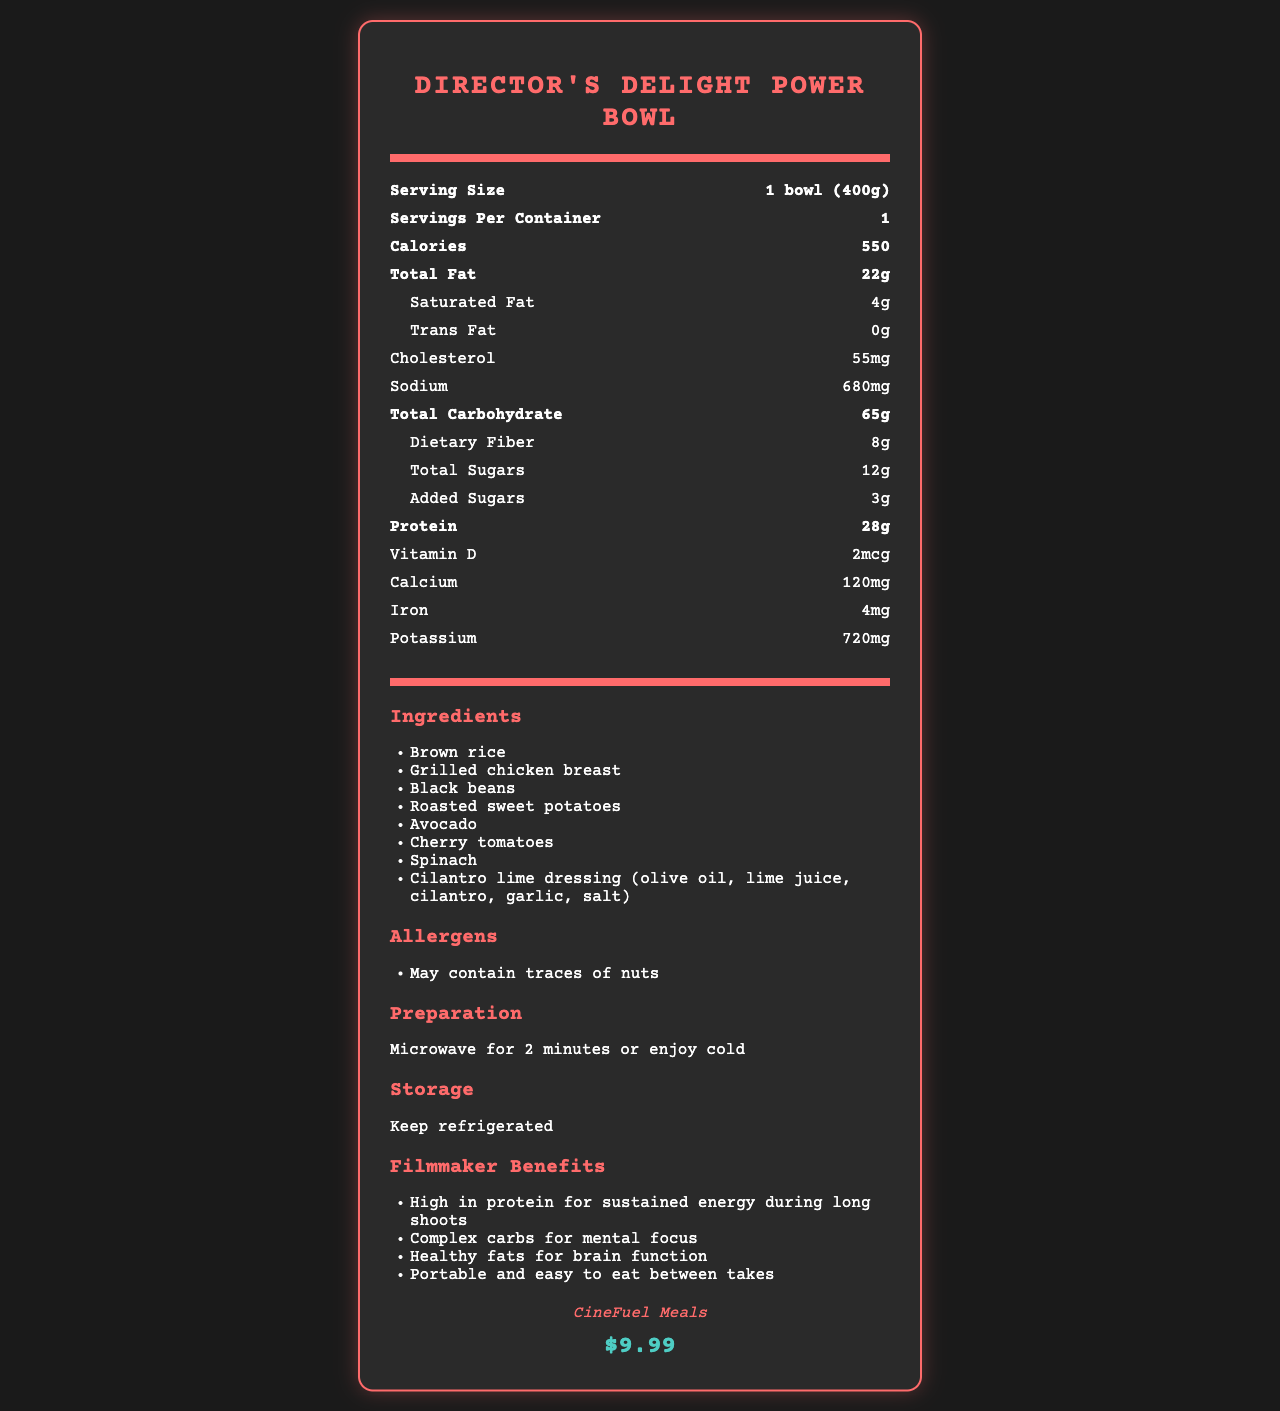what is the serving size of the Director's Delight Power Bowl? The document clearly states that the serving size is "1 bowl (400g)".
Answer: 1 bowl (400g) how many servings are there per container? The document mentions that there is 1 serving per container.
Answer: 1 how many grams of protein are in one serving? The nutritional information lists 28 grams of protein per serving.
Answer: 28 grams what is the total carbohydrate content per serving? The document notes that the total carbohydrate content per serving is 65 grams.
Answer: 65 grams how much total fat does the Director's Delight Power Bowl have? The total fat content in the power bowl is 22 grams, as noted in the nutrition facts.
Answer: 22 grams what are the main ingredients in this meal? A. Chicken, Sweet Potatoes, Rice, Avocado B. Tofu, Kale, Quinoa, Almonds C. Beef, Potatoes, Rice, Cheddar The ingredients listed include Brown rice, Grilled chicken breast, Black beans, Roasted sweet potatoes, Avocado, Cherry tomatoes, Spinach, and Cilantro lime dressing.
Answer: A. Chicken, Sweet Potatoes, Rice, Avocado how should this meal be stored? A. At room temperature B. In the freezer C. In the refrigerator D. In a pantry The preparation section indicates that the meal should be kept refrigerated.
Answer: C. In the refrigerator are there any added sugars in the meal? The document specifies 3 grams of added sugars.
Answer: Yes does this meal contain any allergens? The document includes a note that the meal may contain traces of nuts.
Answer: Yes is this meal high in protein? The meal has 28 grams of protein, which is relatively high.
Answer: Yes describe the main benefits of the Director's Delight Power Bowl for filmmakers. The "Filmmaker Benefits" section highlights these specific advantages for busy film directors.
Answer: The benefits include high protein for sustained energy, complex carbs for mental focus, healthy fats for brain function, and portability for easy consumption between takes. what is the macronutrient ratio of carbohydrates in this meal? According to the macronutrient ratio provided, carbohydrates make up 47% of the total caloric content.
Answer: 47% what is the price of the Director's Delight Power Bowl? The document lists the price as $9.99 under the price section.
Answer: $9.99 are the preparation instructions provided for this meal? The preparation instructions note that the meal can be microwaved for 2 minutes or enjoyed cold.
Answer: Yes how many grams of dietary fiber are in the meal? The nutrition facts state there are 8 grams of dietary fiber.
Answer: 8 grams does the Director's Delight Power Bowl help maintain mental focus? The document mentions that complex carbs in the meal help with mental focus as part of the filmmaker benefits.
Answer: Yes does the nutritional information include details on vitamins and minerals? The nutrition facts include details on Vitamin D, Calcium, Iron, and Potassium.
Answer: Yes can the exact sources of specific nutrients like vitamins and minerals be determined from the ingredients list? While the ingredients list includes various foods, it does not specify which ingredients contribute to the specific vitamin and mineral contents.
Answer: Not enough information 